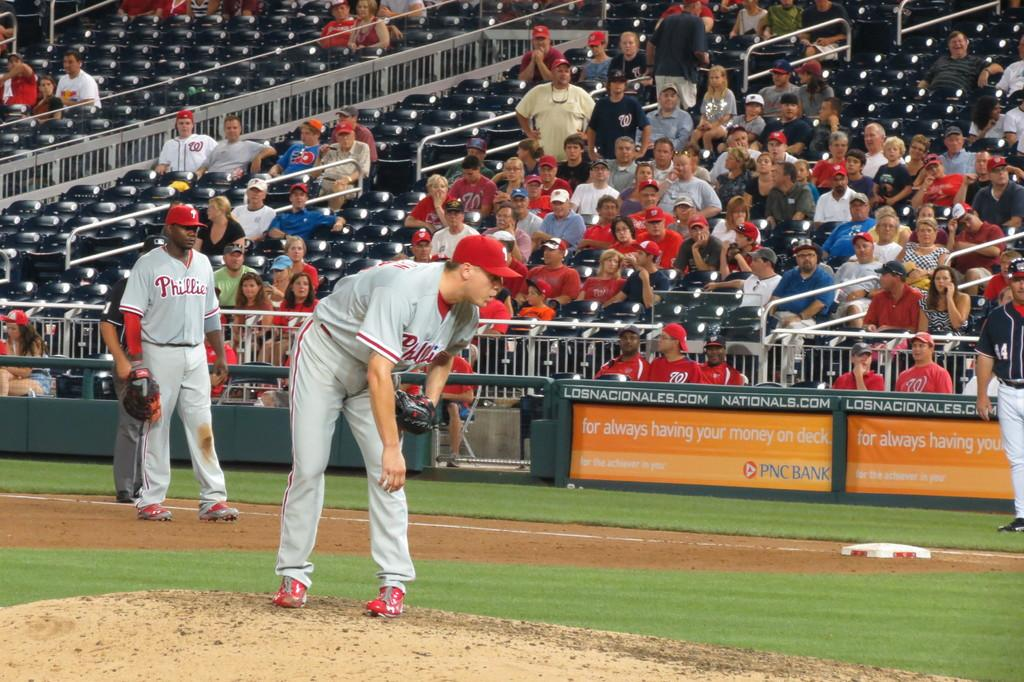<image>
Provide a brief description of the given image. A group of people watching a player pitch with the word Phillies on his shirt 